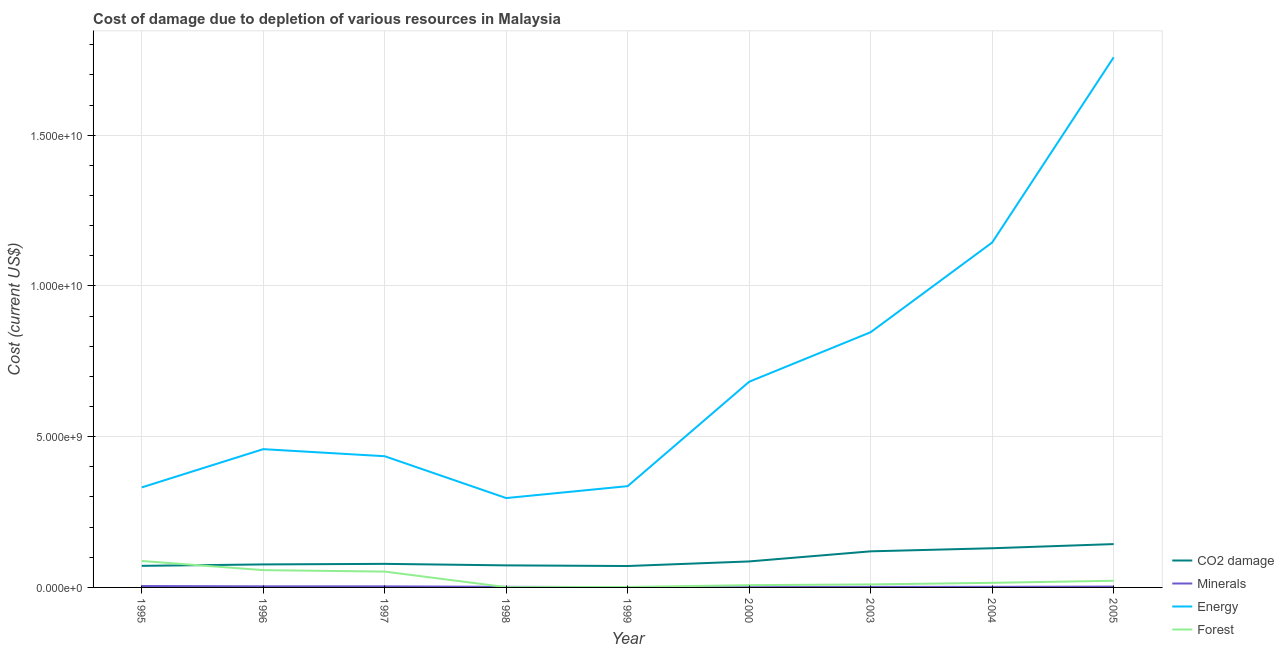How many different coloured lines are there?
Your response must be concise. 4. What is the cost of damage due to depletion of forests in 1995?
Your answer should be very brief. 8.77e+08. Across all years, what is the maximum cost of damage due to depletion of coal?
Keep it short and to the point. 1.44e+09. Across all years, what is the minimum cost of damage due to depletion of coal?
Make the answer very short. 7.10e+08. In which year was the cost of damage due to depletion of coal maximum?
Ensure brevity in your answer.  2005. In which year was the cost of damage due to depletion of minerals minimum?
Offer a very short reply. 2000. What is the total cost of damage due to depletion of minerals in the graph?
Offer a very short reply. 2.23e+08. What is the difference between the cost of damage due to depletion of minerals in 1995 and that in 1999?
Offer a very short reply. 3.65e+07. What is the difference between the cost of damage due to depletion of minerals in 1999 and the cost of damage due to depletion of coal in 2005?
Make the answer very short. -1.43e+09. What is the average cost of damage due to depletion of coal per year?
Make the answer very short. 9.44e+08. In the year 1999, what is the difference between the cost of damage due to depletion of coal and cost of damage due to depletion of energy?
Provide a succinct answer. -2.65e+09. In how many years, is the cost of damage due to depletion of minerals greater than 3000000000 US$?
Your answer should be compact. 0. What is the ratio of the cost of damage due to depletion of minerals in 1997 to that in 2005?
Your response must be concise. 1.25. What is the difference between the highest and the second highest cost of damage due to depletion of forests?
Give a very brief answer. 3.04e+08. What is the difference between the highest and the lowest cost of damage due to depletion of forests?
Keep it short and to the point. 8.68e+08. In how many years, is the cost of damage due to depletion of coal greater than the average cost of damage due to depletion of coal taken over all years?
Offer a very short reply. 3. Is it the case that in every year, the sum of the cost of damage due to depletion of energy and cost of damage due to depletion of minerals is greater than the sum of cost of damage due to depletion of forests and cost of damage due to depletion of coal?
Give a very brief answer. Yes. Is it the case that in every year, the sum of the cost of damage due to depletion of coal and cost of damage due to depletion of minerals is greater than the cost of damage due to depletion of energy?
Provide a short and direct response. No. Does the cost of damage due to depletion of coal monotonically increase over the years?
Ensure brevity in your answer.  No. Is the cost of damage due to depletion of forests strictly less than the cost of damage due to depletion of coal over the years?
Your answer should be compact. No. How many years are there in the graph?
Give a very brief answer. 9. Are the values on the major ticks of Y-axis written in scientific E-notation?
Your answer should be very brief. Yes. Does the graph contain any zero values?
Ensure brevity in your answer.  No. Does the graph contain grids?
Your response must be concise. Yes. How many legend labels are there?
Make the answer very short. 4. What is the title of the graph?
Provide a short and direct response. Cost of damage due to depletion of various resources in Malaysia . Does "Services" appear as one of the legend labels in the graph?
Offer a terse response. No. What is the label or title of the Y-axis?
Keep it short and to the point. Cost (current US$). What is the Cost (current US$) of CO2 damage in 1995?
Provide a short and direct response. 7.16e+08. What is the Cost (current US$) of Minerals in 1995?
Your answer should be compact. 4.67e+07. What is the Cost (current US$) in Energy in 1995?
Offer a very short reply. 3.32e+09. What is the Cost (current US$) in Forest in 1995?
Keep it short and to the point. 8.77e+08. What is the Cost (current US$) in CO2 damage in 1996?
Offer a very short reply. 7.63e+08. What is the Cost (current US$) of Minerals in 1996?
Ensure brevity in your answer.  3.65e+07. What is the Cost (current US$) of Energy in 1996?
Your answer should be very brief. 4.59e+09. What is the Cost (current US$) of Forest in 1996?
Provide a succinct answer. 5.74e+08. What is the Cost (current US$) in CO2 damage in 1997?
Provide a short and direct response. 7.82e+08. What is the Cost (current US$) of Minerals in 1997?
Provide a succinct answer. 3.52e+07. What is the Cost (current US$) in Energy in 1997?
Offer a terse response. 4.35e+09. What is the Cost (current US$) of Forest in 1997?
Provide a short and direct response. 5.25e+08. What is the Cost (current US$) of CO2 damage in 1998?
Make the answer very short. 7.32e+08. What is the Cost (current US$) in Minerals in 1998?
Provide a succinct answer. 2.02e+07. What is the Cost (current US$) in Energy in 1998?
Ensure brevity in your answer.  2.96e+09. What is the Cost (current US$) of Forest in 1998?
Your response must be concise. 9.63e+06. What is the Cost (current US$) of CO2 damage in 1999?
Offer a very short reply. 7.10e+08. What is the Cost (current US$) of Minerals in 1999?
Your answer should be compact. 1.02e+07. What is the Cost (current US$) in Energy in 1999?
Keep it short and to the point. 3.36e+09. What is the Cost (current US$) of Forest in 1999?
Provide a succinct answer. 1.46e+07. What is the Cost (current US$) in CO2 damage in 2000?
Make the answer very short. 8.62e+08. What is the Cost (current US$) of Minerals in 2000?
Your answer should be compact. 7.79e+06. What is the Cost (current US$) of Energy in 2000?
Your response must be concise. 6.82e+09. What is the Cost (current US$) of Forest in 2000?
Your response must be concise. 7.52e+07. What is the Cost (current US$) of CO2 damage in 2003?
Ensure brevity in your answer.  1.20e+09. What is the Cost (current US$) in Minerals in 2003?
Your response must be concise. 1.81e+07. What is the Cost (current US$) of Energy in 2003?
Provide a succinct answer. 8.47e+09. What is the Cost (current US$) in Forest in 2003?
Offer a very short reply. 1.00e+08. What is the Cost (current US$) in CO2 damage in 2004?
Ensure brevity in your answer.  1.30e+09. What is the Cost (current US$) in Minerals in 2004?
Provide a succinct answer. 2.03e+07. What is the Cost (current US$) of Energy in 2004?
Ensure brevity in your answer.  1.14e+1. What is the Cost (current US$) in Forest in 2004?
Give a very brief answer. 1.53e+08. What is the Cost (current US$) in CO2 damage in 2005?
Your answer should be very brief. 1.44e+09. What is the Cost (current US$) in Minerals in 2005?
Your answer should be very brief. 2.82e+07. What is the Cost (current US$) of Energy in 2005?
Provide a short and direct response. 1.76e+1. What is the Cost (current US$) in Forest in 2005?
Provide a succinct answer. 2.21e+08. Across all years, what is the maximum Cost (current US$) of CO2 damage?
Your response must be concise. 1.44e+09. Across all years, what is the maximum Cost (current US$) in Minerals?
Keep it short and to the point. 4.67e+07. Across all years, what is the maximum Cost (current US$) in Energy?
Keep it short and to the point. 1.76e+1. Across all years, what is the maximum Cost (current US$) of Forest?
Keep it short and to the point. 8.77e+08. Across all years, what is the minimum Cost (current US$) in CO2 damage?
Your answer should be very brief. 7.10e+08. Across all years, what is the minimum Cost (current US$) in Minerals?
Ensure brevity in your answer.  7.79e+06. Across all years, what is the minimum Cost (current US$) in Energy?
Your response must be concise. 2.96e+09. Across all years, what is the minimum Cost (current US$) in Forest?
Provide a succinct answer. 9.63e+06. What is the total Cost (current US$) in CO2 damage in the graph?
Your answer should be compact. 8.50e+09. What is the total Cost (current US$) of Minerals in the graph?
Your answer should be very brief. 2.23e+08. What is the total Cost (current US$) of Energy in the graph?
Ensure brevity in your answer.  6.29e+1. What is the total Cost (current US$) of Forest in the graph?
Provide a succinct answer. 2.55e+09. What is the difference between the Cost (current US$) of CO2 damage in 1995 and that in 1996?
Provide a short and direct response. -4.75e+07. What is the difference between the Cost (current US$) in Minerals in 1995 and that in 1996?
Your answer should be compact. 1.02e+07. What is the difference between the Cost (current US$) of Energy in 1995 and that in 1996?
Your response must be concise. -1.27e+09. What is the difference between the Cost (current US$) in Forest in 1995 and that in 1996?
Keep it short and to the point. 3.04e+08. What is the difference between the Cost (current US$) of CO2 damage in 1995 and that in 1997?
Offer a very short reply. -6.62e+07. What is the difference between the Cost (current US$) of Minerals in 1995 and that in 1997?
Ensure brevity in your answer.  1.15e+07. What is the difference between the Cost (current US$) of Energy in 1995 and that in 1997?
Your answer should be compact. -1.03e+09. What is the difference between the Cost (current US$) of Forest in 1995 and that in 1997?
Your answer should be compact. 3.52e+08. What is the difference between the Cost (current US$) in CO2 damage in 1995 and that in 1998?
Ensure brevity in your answer.  -1.58e+07. What is the difference between the Cost (current US$) of Minerals in 1995 and that in 1998?
Provide a short and direct response. 2.65e+07. What is the difference between the Cost (current US$) in Energy in 1995 and that in 1998?
Your answer should be compact. 3.54e+08. What is the difference between the Cost (current US$) of Forest in 1995 and that in 1998?
Keep it short and to the point. 8.68e+08. What is the difference between the Cost (current US$) in CO2 damage in 1995 and that in 1999?
Your answer should be compact. 5.41e+06. What is the difference between the Cost (current US$) of Minerals in 1995 and that in 1999?
Provide a succinct answer. 3.65e+07. What is the difference between the Cost (current US$) in Energy in 1995 and that in 1999?
Provide a succinct answer. -4.26e+07. What is the difference between the Cost (current US$) of Forest in 1995 and that in 1999?
Provide a short and direct response. 8.63e+08. What is the difference between the Cost (current US$) of CO2 damage in 1995 and that in 2000?
Offer a very short reply. -1.46e+08. What is the difference between the Cost (current US$) in Minerals in 1995 and that in 2000?
Keep it short and to the point. 3.89e+07. What is the difference between the Cost (current US$) in Energy in 1995 and that in 2000?
Offer a terse response. -3.51e+09. What is the difference between the Cost (current US$) of Forest in 1995 and that in 2000?
Your answer should be compact. 8.02e+08. What is the difference between the Cost (current US$) in CO2 damage in 1995 and that in 2003?
Provide a short and direct response. -4.82e+08. What is the difference between the Cost (current US$) of Minerals in 1995 and that in 2003?
Your answer should be very brief. 2.86e+07. What is the difference between the Cost (current US$) of Energy in 1995 and that in 2003?
Provide a succinct answer. -5.15e+09. What is the difference between the Cost (current US$) of Forest in 1995 and that in 2003?
Provide a short and direct response. 7.77e+08. What is the difference between the Cost (current US$) in CO2 damage in 1995 and that in 2004?
Give a very brief answer. -5.84e+08. What is the difference between the Cost (current US$) in Minerals in 1995 and that in 2004?
Keep it short and to the point. 2.64e+07. What is the difference between the Cost (current US$) in Energy in 1995 and that in 2004?
Offer a very short reply. -8.12e+09. What is the difference between the Cost (current US$) in Forest in 1995 and that in 2004?
Provide a succinct answer. 7.25e+08. What is the difference between the Cost (current US$) in CO2 damage in 1995 and that in 2005?
Provide a succinct answer. -7.22e+08. What is the difference between the Cost (current US$) of Minerals in 1995 and that in 2005?
Keep it short and to the point. 1.85e+07. What is the difference between the Cost (current US$) in Energy in 1995 and that in 2005?
Ensure brevity in your answer.  -1.43e+1. What is the difference between the Cost (current US$) in Forest in 1995 and that in 2005?
Offer a very short reply. 6.56e+08. What is the difference between the Cost (current US$) in CO2 damage in 1996 and that in 1997?
Ensure brevity in your answer.  -1.87e+07. What is the difference between the Cost (current US$) of Minerals in 1996 and that in 1997?
Offer a very short reply. 1.25e+06. What is the difference between the Cost (current US$) of Energy in 1996 and that in 1997?
Offer a very short reply. 2.35e+08. What is the difference between the Cost (current US$) of Forest in 1996 and that in 1997?
Your response must be concise. 4.82e+07. What is the difference between the Cost (current US$) in CO2 damage in 1996 and that in 1998?
Provide a succinct answer. 3.16e+07. What is the difference between the Cost (current US$) of Minerals in 1996 and that in 1998?
Keep it short and to the point. 1.63e+07. What is the difference between the Cost (current US$) in Energy in 1996 and that in 1998?
Your response must be concise. 1.62e+09. What is the difference between the Cost (current US$) in Forest in 1996 and that in 1998?
Your response must be concise. 5.64e+08. What is the difference between the Cost (current US$) of CO2 damage in 1996 and that in 1999?
Your response must be concise. 5.29e+07. What is the difference between the Cost (current US$) in Minerals in 1996 and that in 1999?
Your response must be concise. 2.62e+07. What is the difference between the Cost (current US$) in Energy in 1996 and that in 1999?
Keep it short and to the point. 1.23e+09. What is the difference between the Cost (current US$) in Forest in 1996 and that in 1999?
Offer a terse response. 5.59e+08. What is the difference between the Cost (current US$) of CO2 damage in 1996 and that in 2000?
Your response must be concise. -9.90e+07. What is the difference between the Cost (current US$) of Minerals in 1996 and that in 2000?
Your response must be concise. 2.87e+07. What is the difference between the Cost (current US$) of Energy in 1996 and that in 2000?
Your response must be concise. -2.24e+09. What is the difference between the Cost (current US$) of Forest in 1996 and that in 2000?
Your answer should be very brief. 4.98e+08. What is the difference between the Cost (current US$) of CO2 damage in 1996 and that in 2003?
Your answer should be very brief. -4.34e+08. What is the difference between the Cost (current US$) of Minerals in 1996 and that in 2003?
Your answer should be compact. 1.84e+07. What is the difference between the Cost (current US$) of Energy in 1996 and that in 2003?
Your answer should be compact. -3.88e+09. What is the difference between the Cost (current US$) in Forest in 1996 and that in 2003?
Offer a very short reply. 4.74e+08. What is the difference between the Cost (current US$) of CO2 damage in 1996 and that in 2004?
Keep it short and to the point. -5.36e+08. What is the difference between the Cost (current US$) in Minerals in 1996 and that in 2004?
Your answer should be compact. 1.62e+07. What is the difference between the Cost (current US$) in Energy in 1996 and that in 2004?
Your answer should be very brief. -6.86e+09. What is the difference between the Cost (current US$) of Forest in 1996 and that in 2004?
Your response must be concise. 4.21e+08. What is the difference between the Cost (current US$) of CO2 damage in 1996 and that in 2005?
Offer a terse response. -6.74e+08. What is the difference between the Cost (current US$) in Minerals in 1996 and that in 2005?
Provide a short and direct response. 8.25e+06. What is the difference between the Cost (current US$) in Energy in 1996 and that in 2005?
Ensure brevity in your answer.  -1.30e+1. What is the difference between the Cost (current US$) in Forest in 1996 and that in 2005?
Make the answer very short. 3.52e+08. What is the difference between the Cost (current US$) in CO2 damage in 1997 and that in 1998?
Offer a very short reply. 5.04e+07. What is the difference between the Cost (current US$) in Minerals in 1997 and that in 1998?
Offer a terse response. 1.50e+07. What is the difference between the Cost (current US$) in Energy in 1997 and that in 1998?
Give a very brief answer. 1.39e+09. What is the difference between the Cost (current US$) in Forest in 1997 and that in 1998?
Offer a very short reply. 5.16e+08. What is the difference between the Cost (current US$) of CO2 damage in 1997 and that in 1999?
Offer a terse response. 7.16e+07. What is the difference between the Cost (current US$) of Minerals in 1997 and that in 1999?
Give a very brief answer. 2.50e+07. What is the difference between the Cost (current US$) in Energy in 1997 and that in 1999?
Give a very brief answer. 9.92e+08. What is the difference between the Cost (current US$) in Forest in 1997 and that in 1999?
Give a very brief answer. 5.11e+08. What is the difference between the Cost (current US$) of CO2 damage in 1997 and that in 2000?
Give a very brief answer. -8.03e+07. What is the difference between the Cost (current US$) of Minerals in 1997 and that in 2000?
Your answer should be compact. 2.74e+07. What is the difference between the Cost (current US$) of Energy in 1997 and that in 2000?
Offer a very short reply. -2.47e+09. What is the difference between the Cost (current US$) of Forest in 1997 and that in 2000?
Make the answer very short. 4.50e+08. What is the difference between the Cost (current US$) of CO2 damage in 1997 and that in 2003?
Make the answer very short. -4.15e+08. What is the difference between the Cost (current US$) in Minerals in 1997 and that in 2003?
Offer a very short reply. 1.71e+07. What is the difference between the Cost (current US$) in Energy in 1997 and that in 2003?
Offer a terse response. -4.11e+09. What is the difference between the Cost (current US$) in Forest in 1997 and that in 2003?
Offer a terse response. 4.25e+08. What is the difference between the Cost (current US$) of CO2 damage in 1997 and that in 2004?
Your response must be concise. -5.18e+08. What is the difference between the Cost (current US$) of Minerals in 1997 and that in 2004?
Provide a short and direct response. 1.49e+07. What is the difference between the Cost (current US$) in Energy in 1997 and that in 2004?
Your answer should be very brief. -7.09e+09. What is the difference between the Cost (current US$) in Forest in 1997 and that in 2004?
Make the answer very short. 3.73e+08. What is the difference between the Cost (current US$) of CO2 damage in 1997 and that in 2005?
Your answer should be very brief. -6.56e+08. What is the difference between the Cost (current US$) in Minerals in 1997 and that in 2005?
Provide a succinct answer. 7.00e+06. What is the difference between the Cost (current US$) of Energy in 1997 and that in 2005?
Provide a succinct answer. -1.32e+1. What is the difference between the Cost (current US$) of Forest in 1997 and that in 2005?
Offer a very short reply. 3.04e+08. What is the difference between the Cost (current US$) in CO2 damage in 1998 and that in 1999?
Your response must be concise. 2.12e+07. What is the difference between the Cost (current US$) of Minerals in 1998 and that in 1999?
Your answer should be very brief. 9.93e+06. What is the difference between the Cost (current US$) of Energy in 1998 and that in 1999?
Offer a terse response. -3.96e+08. What is the difference between the Cost (current US$) in Forest in 1998 and that in 1999?
Make the answer very short. -5.00e+06. What is the difference between the Cost (current US$) in CO2 damage in 1998 and that in 2000?
Provide a short and direct response. -1.31e+08. What is the difference between the Cost (current US$) of Minerals in 1998 and that in 2000?
Provide a short and direct response. 1.24e+07. What is the difference between the Cost (current US$) of Energy in 1998 and that in 2000?
Provide a succinct answer. -3.86e+09. What is the difference between the Cost (current US$) of Forest in 1998 and that in 2000?
Keep it short and to the point. -6.56e+07. What is the difference between the Cost (current US$) of CO2 damage in 1998 and that in 2003?
Your answer should be very brief. -4.66e+08. What is the difference between the Cost (current US$) in Minerals in 1998 and that in 2003?
Give a very brief answer. 2.08e+06. What is the difference between the Cost (current US$) in Energy in 1998 and that in 2003?
Your answer should be compact. -5.50e+09. What is the difference between the Cost (current US$) in Forest in 1998 and that in 2003?
Make the answer very short. -9.05e+07. What is the difference between the Cost (current US$) of CO2 damage in 1998 and that in 2004?
Your answer should be very brief. -5.68e+08. What is the difference between the Cost (current US$) of Minerals in 1998 and that in 2004?
Ensure brevity in your answer.  -1.16e+05. What is the difference between the Cost (current US$) in Energy in 1998 and that in 2004?
Offer a terse response. -8.48e+09. What is the difference between the Cost (current US$) of Forest in 1998 and that in 2004?
Make the answer very short. -1.43e+08. What is the difference between the Cost (current US$) of CO2 damage in 1998 and that in 2005?
Keep it short and to the point. -7.06e+08. What is the difference between the Cost (current US$) in Minerals in 1998 and that in 2005?
Provide a succinct answer. -8.04e+06. What is the difference between the Cost (current US$) of Energy in 1998 and that in 2005?
Your answer should be very brief. -1.46e+1. What is the difference between the Cost (current US$) of Forest in 1998 and that in 2005?
Keep it short and to the point. -2.12e+08. What is the difference between the Cost (current US$) in CO2 damage in 1999 and that in 2000?
Provide a short and direct response. -1.52e+08. What is the difference between the Cost (current US$) in Minerals in 1999 and that in 2000?
Your response must be concise. 2.46e+06. What is the difference between the Cost (current US$) of Energy in 1999 and that in 2000?
Ensure brevity in your answer.  -3.46e+09. What is the difference between the Cost (current US$) of Forest in 1999 and that in 2000?
Ensure brevity in your answer.  -6.06e+07. What is the difference between the Cost (current US$) in CO2 damage in 1999 and that in 2003?
Your answer should be very brief. -4.87e+08. What is the difference between the Cost (current US$) of Minerals in 1999 and that in 2003?
Your answer should be very brief. -7.84e+06. What is the difference between the Cost (current US$) of Energy in 1999 and that in 2003?
Your response must be concise. -5.11e+09. What is the difference between the Cost (current US$) in Forest in 1999 and that in 2003?
Your response must be concise. -8.55e+07. What is the difference between the Cost (current US$) in CO2 damage in 1999 and that in 2004?
Give a very brief answer. -5.89e+08. What is the difference between the Cost (current US$) of Minerals in 1999 and that in 2004?
Offer a very short reply. -1.00e+07. What is the difference between the Cost (current US$) of Energy in 1999 and that in 2004?
Provide a succinct answer. -8.08e+09. What is the difference between the Cost (current US$) of Forest in 1999 and that in 2004?
Offer a very short reply. -1.38e+08. What is the difference between the Cost (current US$) of CO2 damage in 1999 and that in 2005?
Provide a succinct answer. -7.27e+08. What is the difference between the Cost (current US$) of Minerals in 1999 and that in 2005?
Make the answer very short. -1.80e+07. What is the difference between the Cost (current US$) of Energy in 1999 and that in 2005?
Your answer should be very brief. -1.42e+1. What is the difference between the Cost (current US$) of Forest in 1999 and that in 2005?
Make the answer very short. -2.07e+08. What is the difference between the Cost (current US$) of CO2 damage in 2000 and that in 2003?
Offer a terse response. -3.35e+08. What is the difference between the Cost (current US$) of Minerals in 2000 and that in 2003?
Ensure brevity in your answer.  -1.03e+07. What is the difference between the Cost (current US$) in Energy in 2000 and that in 2003?
Ensure brevity in your answer.  -1.64e+09. What is the difference between the Cost (current US$) in Forest in 2000 and that in 2003?
Offer a very short reply. -2.49e+07. What is the difference between the Cost (current US$) in CO2 damage in 2000 and that in 2004?
Your response must be concise. -4.37e+08. What is the difference between the Cost (current US$) of Minerals in 2000 and that in 2004?
Give a very brief answer. -1.25e+07. What is the difference between the Cost (current US$) of Energy in 2000 and that in 2004?
Make the answer very short. -4.62e+09. What is the difference between the Cost (current US$) of Forest in 2000 and that in 2004?
Give a very brief answer. -7.73e+07. What is the difference between the Cost (current US$) in CO2 damage in 2000 and that in 2005?
Provide a succinct answer. -5.75e+08. What is the difference between the Cost (current US$) of Minerals in 2000 and that in 2005?
Provide a succinct answer. -2.04e+07. What is the difference between the Cost (current US$) in Energy in 2000 and that in 2005?
Give a very brief answer. -1.08e+1. What is the difference between the Cost (current US$) of Forest in 2000 and that in 2005?
Your answer should be compact. -1.46e+08. What is the difference between the Cost (current US$) of CO2 damage in 2003 and that in 2004?
Offer a terse response. -1.02e+08. What is the difference between the Cost (current US$) of Minerals in 2003 and that in 2004?
Your response must be concise. -2.20e+06. What is the difference between the Cost (current US$) in Energy in 2003 and that in 2004?
Your response must be concise. -2.98e+09. What is the difference between the Cost (current US$) in Forest in 2003 and that in 2004?
Make the answer very short. -5.24e+07. What is the difference between the Cost (current US$) in CO2 damage in 2003 and that in 2005?
Your response must be concise. -2.40e+08. What is the difference between the Cost (current US$) in Minerals in 2003 and that in 2005?
Your response must be concise. -1.01e+07. What is the difference between the Cost (current US$) of Energy in 2003 and that in 2005?
Your answer should be compact. -9.12e+09. What is the difference between the Cost (current US$) in Forest in 2003 and that in 2005?
Provide a short and direct response. -1.21e+08. What is the difference between the Cost (current US$) of CO2 damage in 2004 and that in 2005?
Ensure brevity in your answer.  -1.38e+08. What is the difference between the Cost (current US$) in Minerals in 2004 and that in 2005?
Give a very brief answer. -7.93e+06. What is the difference between the Cost (current US$) in Energy in 2004 and that in 2005?
Keep it short and to the point. -6.14e+09. What is the difference between the Cost (current US$) of Forest in 2004 and that in 2005?
Keep it short and to the point. -6.86e+07. What is the difference between the Cost (current US$) of CO2 damage in 1995 and the Cost (current US$) of Minerals in 1996?
Offer a terse response. 6.79e+08. What is the difference between the Cost (current US$) of CO2 damage in 1995 and the Cost (current US$) of Energy in 1996?
Your response must be concise. -3.87e+09. What is the difference between the Cost (current US$) of CO2 damage in 1995 and the Cost (current US$) of Forest in 1996?
Provide a short and direct response. 1.42e+08. What is the difference between the Cost (current US$) of Minerals in 1995 and the Cost (current US$) of Energy in 1996?
Your response must be concise. -4.54e+09. What is the difference between the Cost (current US$) in Minerals in 1995 and the Cost (current US$) in Forest in 1996?
Give a very brief answer. -5.27e+08. What is the difference between the Cost (current US$) of Energy in 1995 and the Cost (current US$) of Forest in 1996?
Offer a very short reply. 2.74e+09. What is the difference between the Cost (current US$) of CO2 damage in 1995 and the Cost (current US$) of Minerals in 1997?
Provide a succinct answer. 6.81e+08. What is the difference between the Cost (current US$) in CO2 damage in 1995 and the Cost (current US$) in Energy in 1997?
Make the answer very short. -3.64e+09. What is the difference between the Cost (current US$) of CO2 damage in 1995 and the Cost (current US$) of Forest in 1997?
Offer a terse response. 1.90e+08. What is the difference between the Cost (current US$) in Minerals in 1995 and the Cost (current US$) in Energy in 1997?
Your response must be concise. -4.31e+09. What is the difference between the Cost (current US$) of Minerals in 1995 and the Cost (current US$) of Forest in 1997?
Ensure brevity in your answer.  -4.79e+08. What is the difference between the Cost (current US$) of Energy in 1995 and the Cost (current US$) of Forest in 1997?
Offer a terse response. 2.79e+09. What is the difference between the Cost (current US$) of CO2 damage in 1995 and the Cost (current US$) of Minerals in 1998?
Ensure brevity in your answer.  6.96e+08. What is the difference between the Cost (current US$) in CO2 damage in 1995 and the Cost (current US$) in Energy in 1998?
Offer a terse response. -2.25e+09. What is the difference between the Cost (current US$) of CO2 damage in 1995 and the Cost (current US$) of Forest in 1998?
Your answer should be very brief. 7.06e+08. What is the difference between the Cost (current US$) of Minerals in 1995 and the Cost (current US$) of Energy in 1998?
Your response must be concise. -2.92e+09. What is the difference between the Cost (current US$) of Minerals in 1995 and the Cost (current US$) of Forest in 1998?
Offer a terse response. 3.71e+07. What is the difference between the Cost (current US$) in Energy in 1995 and the Cost (current US$) in Forest in 1998?
Your response must be concise. 3.31e+09. What is the difference between the Cost (current US$) in CO2 damage in 1995 and the Cost (current US$) in Minerals in 1999?
Your answer should be compact. 7.06e+08. What is the difference between the Cost (current US$) of CO2 damage in 1995 and the Cost (current US$) of Energy in 1999?
Ensure brevity in your answer.  -2.64e+09. What is the difference between the Cost (current US$) of CO2 damage in 1995 and the Cost (current US$) of Forest in 1999?
Your answer should be very brief. 7.01e+08. What is the difference between the Cost (current US$) in Minerals in 1995 and the Cost (current US$) in Energy in 1999?
Provide a short and direct response. -3.31e+09. What is the difference between the Cost (current US$) of Minerals in 1995 and the Cost (current US$) of Forest in 1999?
Offer a very short reply. 3.21e+07. What is the difference between the Cost (current US$) of Energy in 1995 and the Cost (current US$) of Forest in 1999?
Provide a succinct answer. 3.30e+09. What is the difference between the Cost (current US$) of CO2 damage in 1995 and the Cost (current US$) of Minerals in 2000?
Offer a terse response. 7.08e+08. What is the difference between the Cost (current US$) of CO2 damage in 1995 and the Cost (current US$) of Energy in 2000?
Keep it short and to the point. -6.11e+09. What is the difference between the Cost (current US$) in CO2 damage in 1995 and the Cost (current US$) in Forest in 2000?
Your answer should be compact. 6.41e+08. What is the difference between the Cost (current US$) in Minerals in 1995 and the Cost (current US$) in Energy in 2000?
Make the answer very short. -6.78e+09. What is the difference between the Cost (current US$) of Minerals in 1995 and the Cost (current US$) of Forest in 2000?
Your answer should be compact. -2.85e+07. What is the difference between the Cost (current US$) of Energy in 1995 and the Cost (current US$) of Forest in 2000?
Keep it short and to the point. 3.24e+09. What is the difference between the Cost (current US$) in CO2 damage in 1995 and the Cost (current US$) in Minerals in 2003?
Your response must be concise. 6.98e+08. What is the difference between the Cost (current US$) in CO2 damage in 1995 and the Cost (current US$) in Energy in 2003?
Give a very brief answer. -7.75e+09. What is the difference between the Cost (current US$) of CO2 damage in 1995 and the Cost (current US$) of Forest in 2003?
Your response must be concise. 6.16e+08. What is the difference between the Cost (current US$) of Minerals in 1995 and the Cost (current US$) of Energy in 2003?
Give a very brief answer. -8.42e+09. What is the difference between the Cost (current US$) of Minerals in 1995 and the Cost (current US$) of Forest in 2003?
Ensure brevity in your answer.  -5.34e+07. What is the difference between the Cost (current US$) in Energy in 1995 and the Cost (current US$) in Forest in 2003?
Your answer should be compact. 3.22e+09. What is the difference between the Cost (current US$) in CO2 damage in 1995 and the Cost (current US$) in Minerals in 2004?
Your answer should be compact. 6.96e+08. What is the difference between the Cost (current US$) in CO2 damage in 1995 and the Cost (current US$) in Energy in 2004?
Offer a terse response. -1.07e+1. What is the difference between the Cost (current US$) of CO2 damage in 1995 and the Cost (current US$) of Forest in 2004?
Offer a terse response. 5.63e+08. What is the difference between the Cost (current US$) of Minerals in 1995 and the Cost (current US$) of Energy in 2004?
Your response must be concise. -1.14e+1. What is the difference between the Cost (current US$) of Minerals in 1995 and the Cost (current US$) of Forest in 2004?
Your response must be concise. -1.06e+08. What is the difference between the Cost (current US$) in Energy in 1995 and the Cost (current US$) in Forest in 2004?
Your response must be concise. 3.17e+09. What is the difference between the Cost (current US$) in CO2 damage in 1995 and the Cost (current US$) in Minerals in 2005?
Make the answer very short. 6.88e+08. What is the difference between the Cost (current US$) in CO2 damage in 1995 and the Cost (current US$) in Energy in 2005?
Provide a succinct answer. -1.69e+1. What is the difference between the Cost (current US$) in CO2 damage in 1995 and the Cost (current US$) in Forest in 2005?
Your response must be concise. 4.95e+08. What is the difference between the Cost (current US$) of Minerals in 1995 and the Cost (current US$) of Energy in 2005?
Make the answer very short. -1.75e+1. What is the difference between the Cost (current US$) in Minerals in 1995 and the Cost (current US$) in Forest in 2005?
Provide a short and direct response. -1.75e+08. What is the difference between the Cost (current US$) in Energy in 1995 and the Cost (current US$) in Forest in 2005?
Provide a short and direct response. 3.10e+09. What is the difference between the Cost (current US$) of CO2 damage in 1996 and the Cost (current US$) of Minerals in 1997?
Your response must be concise. 7.28e+08. What is the difference between the Cost (current US$) in CO2 damage in 1996 and the Cost (current US$) in Energy in 1997?
Keep it short and to the point. -3.59e+09. What is the difference between the Cost (current US$) of CO2 damage in 1996 and the Cost (current US$) of Forest in 1997?
Your answer should be compact. 2.38e+08. What is the difference between the Cost (current US$) in Minerals in 1996 and the Cost (current US$) in Energy in 1997?
Your response must be concise. -4.32e+09. What is the difference between the Cost (current US$) of Minerals in 1996 and the Cost (current US$) of Forest in 1997?
Keep it short and to the point. -4.89e+08. What is the difference between the Cost (current US$) of Energy in 1996 and the Cost (current US$) of Forest in 1997?
Ensure brevity in your answer.  4.06e+09. What is the difference between the Cost (current US$) of CO2 damage in 1996 and the Cost (current US$) of Minerals in 1998?
Provide a succinct answer. 7.43e+08. What is the difference between the Cost (current US$) of CO2 damage in 1996 and the Cost (current US$) of Energy in 1998?
Your answer should be very brief. -2.20e+09. What is the difference between the Cost (current US$) in CO2 damage in 1996 and the Cost (current US$) in Forest in 1998?
Your answer should be compact. 7.54e+08. What is the difference between the Cost (current US$) of Minerals in 1996 and the Cost (current US$) of Energy in 1998?
Keep it short and to the point. -2.93e+09. What is the difference between the Cost (current US$) in Minerals in 1996 and the Cost (current US$) in Forest in 1998?
Ensure brevity in your answer.  2.68e+07. What is the difference between the Cost (current US$) of Energy in 1996 and the Cost (current US$) of Forest in 1998?
Offer a very short reply. 4.58e+09. What is the difference between the Cost (current US$) of CO2 damage in 1996 and the Cost (current US$) of Minerals in 1999?
Offer a very short reply. 7.53e+08. What is the difference between the Cost (current US$) in CO2 damage in 1996 and the Cost (current US$) in Energy in 1999?
Ensure brevity in your answer.  -2.60e+09. What is the difference between the Cost (current US$) of CO2 damage in 1996 and the Cost (current US$) of Forest in 1999?
Make the answer very short. 7.49e+08. What is the difference between the Cost (current US$) of Minerals in 1996 and the Cost (current US$) of Energy in 1999?
Ensure brevity in your answer.  -3.32e+09. What is the difference between the Cost (current US$) of Minerals in 1996 and the Cost (current US$) of Forest in 1999?
Make the answer very short. 2.18e+07. What is the difference between the Cost (current US$) of Energy in 1996 and the Cost (current US$) of Forest in 1999?
Make the answer very short. 4.57e+09. What is the difference between the Cost (current US$) of CO2 damage in 1996 and the Cost (current US$) of Minerals in 2000?
Offer a terse response. 7.55e+08. What is the difference between the Cost (current US$) of CO2 damage in 1996 and the Cost (current US$) of Energy in 2000?
Offer a terse response. -6.06e+09. What is the difference between the Cost (current US$) in CO2 damage in 1996 and the Cost (current US$) in Forest in 2000?
Your answer should be very brief. 6.88e+08. What is the difference between the Cost (current US$) in Minerals in 1996 and the Cost (current US$) in Energy in 2000?
Give a very brief answer. -6.79e+09. What is the difference between the Cost (current US$) of Minerals in 1996 and the Cost (current US$) of Forest in 2000?
Give a very brief answer. -3.88e+07. What is the difference between the Cost (current US$) of Energy in 1996 and the Cost (current US$) of Forest in 2000?
Offer a terse response. 4.51e+09. What is the difference between the Cost (current US$) of CO2 damage in 1996 and the Cost (current US$) of Minerals in 2003?
Ensure brevity in your answer.  7.45e+08. What is the difference between the Cost (current US$) of CO2 damage in 1996 and the Cost (current US$) of Energy in 2003?
Provide a succinct answer. -7.70e+09. What is the difference between the Cost (current US$) of CO2 damage in 1996 and the Cost (current US$) of Forest in 2003?
Provide a short and direct response. 6.63e+08. What is the difference between the Cost (current US$) of Minerals in 1996 and the Cost (current US$) of Energy in 2003?
Your answer should be compact. -8.43e+09. What is the difference between the Cost (current US$) of Minerals in 1996 and the Cost (current US$) of Forest in 2003?
Give a very brief answer. -6.37e+07. What is the difference between the Cost (current US$) in Energy in 1996 and the Cost (current US$) in Forest in 2003?
Your response must be concise. 4.49e+09. What is the difference between the Cost (current US$) in CO2 damage in 1996 and the Cost (current US$) in Minerals in 2004?
Provide a short and direct response. 7.43e+08. What is the difference between the Cost (current US$) in CO2 damage in 1996 and the Cost (current US$) in Energy in 2004?
Provide a short and direct response. -1.07e+1. What is the difference between the Cost (current US$) of CO2 damage in 1996 and the Cost (current US$) of Forest in 2004?
Your answer should be very brief. 6.11e+08. What is the difference between the Cost (current US$) in Minerals in 1996 and the Cost (current US$) in Energy in 2004?
Keep it short and to the point. -1.14e+1. What is the difference between the Cost (current US$) in Minerals in 1996 and the Cost (current US$) in Forest in 2004?
Keep it short and to the point. -1.16e+08. What is the difference between the Cost (current US$) in Energy in 1996 and the Cost (current US$) in Forest in 2004?
Your response must be concise. 4.43e+09. What is the difference between the Cost (current US$) of CO2 damage in 1996 and the Cost (current US$) of Minerals in 2005?
Keep it short and to the point. 7.35e+08. What is the difference between the Cost (current US$) of CO2 damage in 1996 and the Cost (current US$) of Energy in 2005?
Keep it short and to the point. -1.68e+1. What is the difference between the Cost (current US$) in CO2 damage in 1996 and the Cost (current US$) in Forest in 2005?
Make the answer very short. 5.42e+08. What is the difference between the Cost (current US$) of Minerals in 1996 and the Cost (current US$) of Energy in 2005?
Keep it short and to the point. -1.75e+1. What is the difference between the Cost (current US$) in Minerals in 1996 and the Cost (current US$) in Forest in 2005?
Provide a short and direct response. -1.85e+08. What is the difference between the Cost (current US$) in Energy in 1996 and the Cost (current US$) in Forest in 2005?
Offer a terse response. 4.37e+09. What is the difference between the Cost (current US$) of CO2 damage in 1997 and the Cost (current US$) of Minerals in 1998?
Provide a short and direct response. 7.62e+08. What is the difference between the Cost (current US$) of CO2 damage in 1997 and the Cost (current US$) of Energy in 1998?
Offer a very short reply. -2.18e+09. What is the difference between the Cost (current US$) of CO2 damage in 1997 and the Cost (current US$) of Forest in 1998?
Offer a terse response. 7.72e+08. What is the difference between the Cost (current US$) of Minerals in 1997 and the Cost (current US$) of Energy in 1998?
Provide a succinct answer. -2.93e+09. What is the difference between the Cost (current US$) in Minerals in 1997 and the Cost (current US$) in Forest in 1998?
Offer a terse response. 2.56e+07. What is the difference between the Cost (current US$) in Energy in 1997 and the Cost (current US$) in Forest in 1998?
Offer a terse response. 4.34e+09. What is the difference between the Cost (current US$) of CO2 damage in 1997 and the Cost (current US$) of Minerals in 1999?
Your answer should be very brief. 7.72e+08. What is the difference between the Cost (current US$) in CO2 damage in 1997 and the Cost (current US$) in Energy in 1999?
Give a very brief answer. -2.58e+09. What is the difference between the Cost (current US$) of CO2 damage in 1997 and the Cost (current US$) of Forest in 1999?
Offer a very short reply. 7.67e+08. What is the difference between the Cost (current US$) in Minerals in 1997 and the Cost (current US$) in Energy in 1999?
Offer a very short reply. -3.33e+09. What is the difference between the Cost (current US$) in Minerals in 1997 and the Cost (current US$) in Forest in 1999?
Your answer should be very brief. 2.06e+07. What is the difference between the Cost (current US$) of Energy in 1997 and the Cost (current US$) of Forest in 1999?
Your answer should be very brief. 4.34e+09. What is the difference between the Cost (current US$) in CO2 damage in 1997 and the Cost (current US$) in Minerals in 2000?
Provide a short and direct response. 7.74e+08. What is the difference between the Cost (current US$) of CO2 damage in 1997 and the Cost (current US$) of Energy in 2000?
Your answer should be compact. -6.04e+09. What is the difference between the Cost (current US$) of CO2 damage in 1997 and the Cost (current US$) of Forest in 2000?
Provide a short and direct response. 7.07e+08. What is the difference between the Cost (current US$) of Minerals in 1997 and the Cost (current US$) of Energy in 2000?
Provide a succinct answer. -6.79e+09. What is the difference between the Cost (current US$) in Minerals in 1997 and the Cost (current US$) in Forest in 2000?
Your answer should be compact. -4.00e+07. What is the difference between the Cost (current US$) of Energy in 1997 and the Cost (current US$) of Forest in 2000?
Offer a terse response. 4.28e+09. What is the difference between the Cost (current US$) of CO2 damage in 1997 and the Cost (current US$) of Minerals in 2003?
Your answer should be compact. 7.64e+08. What is the difference between the Cost (current US$) in CO2 damage in 1997 and the Cost (current US$) in Energy in 2003?
Offer a very short reply. -7.68e+09. What is the difference between the Cost (current US$) in CO2 damage in 1997 and the Cost (current US$) in Forest in 2003?
Keep it short and to the point. 6.82e+08. What is the difference between the Cost (current US$) in Minerals in 1997 and the Cost (current US$) in Energy in 2003?
Your answer should be compact. -8.43e+09. What is the difference between the Cost (current US$) in Minerals in 1997 and the Cost (current US$) in Forest in 2003?
Ensure brevity in your answer.  -6.49e+07. What is the difference between the Cost (current US$) of Energy in 1997 and the Cost (current US$) of Forest in 2003?
Provide a short and direct response. 4.25e+09. What is the difference between the Cost (current US$) of CO2 damage in 1997 and the Cost (current US$) of Minerals in 2004?
Ensure brevity in your answer.  7.62e+08. What is the difference between the Cost (current US$) in CO2 damage in 1997 and the Cost (current US$) in Energy in 2004?
Your answer should be compact. -1.07e+1. What is the difference between the Cost (current US$) of CO2 damage in 1997 and the Cost (current US$) of Forest in 2004?
Offer a very short reply. 6.29e+08. What is the difference between the Cost (current US$) in Minerals in 1997 and the Cost (current US$) in Energy in 2004?
Make the answer very short. -1.14e+1. What is the difference between the Cost (current US$) in Minerals in 1997 and the Cost (current US$) in Forest in 2004?
Offer a very short reply. -1.17e+08. What is the difference between the Cost (current US$) of Energy in 1997 and the Cost (current US$) of Forest in 2004?
Your response must be concise. 4.20e+09. What is the difference between the Cost (current US$) of CO2 damage in 1997 and the Cost (current US$) of Minerals in 2005?
Make the answer very short. 7.54e+08. What is the difference between the Cost (current US$) in CO2 damage in 1997 and the Cost (current US$) in Energy in 2005?
Offer a very short reply. -1.68e+1. What is the difference between the Cost (current US$) of CO2 damage in 1997 and the Cost (current US$) of Forest in 2005?
Provide a short and direct response. 5.61e+08. What is the difference between the Cost (current US$) of Minerals in 1997 and the Cost (current US$) of Energy in 2005?
Your answer should be compact. -1.75e+1. What is the difference between the Cost (current US$) of Minerals in 1997 and the Cost (current US$) of Forest in 2005?
Make the answer very short. -1.86e+08. What is the difference between the Cost (current US$) of Energy in 1997 and the Cost (current US$) of Forest in 2005?
Offer a terse response. 4.13e+09. What is the difference between the Cost (current US$) in CO2 damage in 1998 and the Cost (current US$) in Minerals in 1999?
Offer a terse response. 7.21e+08. What is the difference between the Cost (current US$) of CO2 damage in 1998 and the Cost (current US$) of Energy in 1999?
Offer a very short reply. -2.63e+09. What is the difference between the Cost (current US$) of CO2 damage in 1998 and the Cost (current US$) of Forest in 1999?
Make the answer very short. 7.17e+08. What is the difference between the Cost (current US$) in Minerals in 1998 and the Cost (current US$) in Energy in 1999?
Ensure brevity in your answer.  -3.34e+09. What is the difference between the Cost (current US$) of Minerals in 1998 and the Cost (current US$) of Forest in 1999?
Provide a succinct answer. 5.55e+06. What is the difference between the Cost (current US$) in Energy in 1998 and the Cost (current US$) in Forest in 1999?
Ensure brevity in your answer.  2.95e+09. What is the difference between the Cost (current US$) in CO2 damage in 1998 and the Cost (current US$) in Minerals in 2000?
Offer a very short reply. 7.24e+08. What is the difference between the Cost (current US$) in CO2 damage in 1998 and the Cost (current US$) in Energy in 2000?
Keep it short and to the point. -6.09e+09. What is the difference between the Cost (current US$) of CO2 damage in 1998 and the Cost (current US$) of Forest in 2000?
Give a very brief answer. 6.56e+08. What is the difference between the Cost (current US$) in Minerals in 1998 and the Cost (current US$) in Energy in 2000?
Give a very brief answer. -6.80e+09. What is the difference between the Cost (current US$) in Minerals in 1998 and the Cost (current US$) in Forest in 2000?
Make the answer very short. -5.51e+07. What is the difference between the Cost (current US$) of Energy in 1998 and the Cost (current US$) of Forest in 2000?
Your response must be concise. 2.89e+09. What is the difference between the Cost (current US$) of CO2 damage in 1998 and the Cost (current US$) of Minerals in 2003?
Provide a succinct answer. 7.14e+08. What is the difference between the Cost (current US$) in CO2 damage in 1998 and the Cost (current US$) in Energy in 2003?
Provide a short and direct response. -7.73e+09. What is the difference between the Cost (current US$) in CO2 damage in 1998 and the Cost (current US$) in Forest in 2003?
Give a very brief answer. 6.31e+08. What is the difference between the Cost (current US$) in Minerals in 1998 and the Cost (current US$) in Energy in 2003?
Ensure brevity in your answer.  -8.45e+09. What is the difference between the Cost (current US$) of Minerals in 1998 and the Cost (current US$) of Forest in 2003?
Give a very brief answer. -8.00e+07. What is the difference between the Cost (current US$) in Energy in 1998 and the Cost (current US$) in Forest in 2003?
Your answer should be compact. 2.86e+09. What is the difference between the Cost (current US$) of CO2 damage in 1998 and the Cost (current US$) of Minerals in 2004?
Your response must be concise. 7.11e+08. What is the difference between the Cost (current US$) of CO2 damage in 1998 and the Cost (current US$) of Energy in 2004?
Give a very brief answer. -1.07e+1. What is the difference between the Cost (current US$) in CO2 damage in 1998 and the Cost (current US$) in Forest in 2004?
Make the answer very short. 5.79e+08. What is the difference between the Cost (current US$) in Minerals in 1998 and the Cost (current US$) in Energy in 2004?
Make the answer very short. -1.14e+1. What is the difference between the Cost (current US$) of Minerals in 1998 and the Cost (current US$) of Forest in 2004?
Ensure brevity in your answer.  -1.32e+08. What is the difference between the Cost (current US$) in Energy in 1998 and the Cost (current US$) in Forest in 2004?
Your answer should be compact. 2.81e+09. What is the difference between the Cost (current US$) of CO2 damage in 1998 and the Cost (current US$) of Minerals in 2005?
Your response must be concise. 7.03e+08. What is the difference between the Cost (current US$) of CO2 damage in 1998 and the Cost (current US$) of Energy in 2005?
Keep it short and to the point. -1.69e+1. What is the difference between the Cost (current US$) in CO2 damage in 1998 and the Cost (current US$) in Forest in 2005?
Offer a very short reply. 5.10e+08. What is the difference between the Cost (current US$) in Minerals in 1998 and the Cost (current US$) in Energy in 2005?
Provide a succinct answer. -1.76e+1. What is the difference between the Cost (current US$) in Minerals in 1998 and the Cost (current US$) in Forest in 2005?
Offer a terse response. -2.01e+08. What is the difference between the Cost (current US$) of Energy in 1998 and the Cost (current US$) of Forest in 2005?
Offer a terse response. 2.74e+09. What is the difference between the Cost (current US$) in CO2 damage in 1999 and the Cost (current US$) in Minerals in 2000?
Make the answer very short. 7.03e+08. What is the difference between the Cost (current US$) in CO2 damage in 1999 and the Cost (current US$) in Energy in 2000?
Make the answer very short. -6.11e+09. What is the difference between the Cost (current US$) of CO2 damage in 1999 and the Cost (current US$) of Forest in 2000?
Ensure brevity in your answer.  6.35e+08. What is the difference between the Cost (current US$) of Minerals in 1999 and the Cost (current US$) of Energy in 2000?
Offer a very short reply. -6.81e+09. What is the difference between the Cost (current US$) of Minerals in 1999 and the Cost (current US$) of Forest in 2000?
Ensure brevity in your answer.  -6.50e+07. What is the difference between the Cost (current US$) of Energy in 1999 and the Cost (current US$) of Forest in 2000?
Offer a terse response. 3.29e+09. What is the difference between the Cost (current US$) of CO2 damage in 1999 and the Cost (current US$) of Minerals in 2003?
Ensure brevity in your answer.  6.92e+08. What is the difference between the Cost (current US$) of CO2 damage in 1999 and the Cost (current US$) of Energy in 2003?
Ensure brevity in your answer.  -7.76e+09. What is the difference between the Cost (current US$) in CO2 damage in 1999 and the Cost (current US$) in Forest in 2003?
Your answer should be very brief. 6.10e+08. What is the difference between the Cost (current US$) of Minerals in 1999 and the Cost (current US$) of Energy in 2003?
Your response must be concise. -8.46e+09. What is the difference between the Cost (current US$) in Minerals in 1999 and the Cost (current US$) in Forest in 2003?
Your answer should be compact. -8.99e+07. What is the difference between the Cost (current US$) in Energy in 1999 and the Cost (current US$) in Forest in 2003?
Keep it short and to the point. 3.26e+09. What is the difference between the Cost (current US$) of CO2 damage in 1999 and the Cost (current US$) of Minerals in 2004?
Provide a succinct answer. 6.90e+08. What is the difference between the Cost (current US$) of CO2 damage in 1999 and the Cost (current US$) of Energy in 2004?
Your answer should be very brief. -1.07e+1. What is the difference between the Cost (current US$) of CO2 damage in 1999 and the Cost (current US$) of Forest in 2004?
Provide a succinct answer. 5.58e+08. What is the difference between the Cost (current US$) of Minerals in 1999 and the Cost (current US$) of Energy in 2004?
Provide a short and direct response. -1.14e+1. What is the difference between the Cost (current US$) in Minerals in 1999 and the Cost (current US$) in Forest in 2004?
Your response must be concise. -1.42e+08. What is the difference between the Cost (current US$) of Energy in 1999 and the Cost (current US$) of Forest in 2004?
Make the answer very short. 3.21e+09. What is the difference between the Cost (current US$) in CO2 damage in 1999 and the Cost (current US$) in Minerals in 2005?
Offer a terse response. 6.82e+08. What is the difference between the Cost (current US$) in CO2 damage in 1999 and the Cost (current US$) in Energy in 2005?
Give a very brief answer. -1.69e+1. What is the difference between the Cost (current US$) of CO2 damage in 1999 and the Cost (current US$) of Forest in 2005?
Your answer should be very brief. 4.89e+08. What is the difference between the Cost (current US$) in Minerals in 1999 and the Cost (current US$) in Energy in 2005?
Your answer should be very brief. -1.76e+1. What is the difference between the Cost (current US$) of Minerals in 1999 and the Cost (current US$) of Forest in 2005?
Give a very brief answer. -2.11e+08. What is the difference between the Cost (current US$) in Energy in 1999 and the Cost (current US$) in Forest in 2005?
Provide a succinct answer. 3.14e+09. What is the difference between the Cost (current US$) in CO2 damage in 2000 and the Cost (current US$) in Minerals in 2003?
Your answer should be very brief. 8.44e+08. What is the difference between the Cost (current US$) of CO2 damage in 2000 and the Cost (current US$) of Energy in 2003?
Keep it short and to the point. -7.60e+09. What is the difference between the Cost (current US$) in CO2 damage in 2000 and the Cost (current US$) in Forest in 2003?
Your answer should be compact. 7.62e+08. What is the difference between the Cost (current US$) in Minerals in 2000 and the Cost (current US$) in Energy in 2003?
Your answer should be very brief. -8.46e+09. What is the difference between the Cost (current US$) of Minerals in 2000 and the Cost (current US$) of Forest in 2003?
Your response must be concise. -9.24e+07. What is the difference between the Cost (current US$) in Energy in 2000 and the Cost (current US$) in Forest in 2003?
Ensure brevity in your answer.  6.72e+09. What is the difference between the Cost (current US$) of CO2 damage in 2000 and the Cost (current US$) of Minerals in 2004?
Offer a very short reply. 8.42e+08. What is the difference between the Cost (current US$) in CO2 damage in 2000 and the Cost (current US$) in Energy in 2004?
Ensure brevity in your answer.  -1.06e+1. What is the difference between the Cost (current US$) in CO2 damage in 2000 and the Cost (current US$) in Forest in 2004?
Ensure brevity in your answer.  7.10e+08. What is the difference between the Cost (current US$) in Minerals in 2000 and the Cost (current US$) in Energy in 2004?
Offer a very short reply. -1.14e+1. What is the difference between the Cost (current US$) of Minerals in 2000 and the Cost (current US$) of Forest in 2004?
Keep it short and to the point. -1.45e+08. What is the difference between the Cost (current US$) in Energy in 2000 and the Cost (current US$) in Forest in 2004?
Give a very brief answer. 6.67e+09. What is the difference between the Cost (current US$) in CO2 damage in 2000 and the Cost (current US$) in Minerals in 2005?
Provide a short and direct response. 8.34e+08. What is the difference between the Cost (current US$) in CO2 damage in 2000 and the Cost (current US$) in Energy in 2005?
Make the answer very short. -1.67e+1. What is the difference between the Cost (current US$) in CO2 damage in 2000 and the Cost (current US$) in Forest in 2005?
Keep it short and to the point. 6.41e+08. What is the difference between the Cost (current US$) in Minerals in 2000 and the Cost (current US$) in Energy in 2005?
Your answer should be very brief. -1.76e+1. What is the difference between the Cost (current US$) of Minerals in 2000 and the Cost (current US$) of Forest in 2005?
Give a very brief answer. -2.13e+08. What is the difference between the Cost (current US$) in Energy in 2000 and the Cost (current US$) in Forest in 2005?
Your answer should be compact. 6.60e+09. What is the difference between the Cost (current US$) in CO2 damage in 2003 and the Cost (current US$) in Minerals in 2004?
Offer a terse response. 1.18e+09. What is the difference between the Cost (current US$) of CO2 damage in 2003 and the Cost (current US$) of Energy in 2004?
Your response must be concise. -1.02e+1. What is the difference between the Cost (current US$) of CO2 damage in 2003 and the Cost (current US$) of Forest in 2004?
Your answer should be compact. 1.04e+09. What is the difference between the Cost (current US$) in Minerals in 2003 and the Cost (current US$) in Energy in 2004?
Keep it short and to the point. -1.14e+1. What is the difference between the Cost (current US$) in Minerals in 2003 and the Cost (current US$) in Forest in 2004?
Ensure brevity in your answer.  -1.34e+08. What is the difference between the Cost (current US$) in Energy in 2003 and the Cost (current US$) in Forest in 2004?
Provide a succinct answer. 8.31e+09. What is the difference between the Cost (current US$) in CO2 damage in 2003 and the Cost (current US$) in Minerals in 2005?
Give a very brief answer. 1.17e+09. What is the difference between the Cost (current US$) in CO2 damage in 2003 and the Cost (current US$) in Energy in 2005?
Your answer should be very brief. -1.64e+1. What is the difference between the Cost (current US$) in CO2 damage in 2003 and the Cost (current US$) in Forest in 2005?
Provide a short and direct response. 9.76e+08. What is the difference between the Cost (current US$) in Minerals in 2003 and the Cost (current US$) in Energy in 2005?
Ensure brevity in your answer.  -1.76e+1. What is the difference between the Cost (current US$) of Minerals in 2003 and the Cost (current US$) of Forest in 2005?
Offer a very short reply. -2.03e+08. What is the difference between the Cost (current US$) in Energy in 2003 and the Cost (current US$) in Forest in 2005?
Your answer should be very brief. 8.25e+09. What is the difference between the Cost (current US$) of CO2 damage in 2004 and the Cost (current US$) of Minerals in 2005?
Give a very brief answer. 1.27e+09. What is the difference between the Cost (current US$) of CO2 damage in 2004 and the Cost (current US$) of Energy in 2005?
Provide a succinct answer. -1.63e+1. What is the difference between the Cost (current US$) of CO2 damage in 2004 and the Cost (current US$) of Forest in 2005?
Ensure brevity in your answer.  1.08e+09. What is the difference between the Cost (current US$) of Minerals in 2004 and the Cost (current US$) of Energy in 2005?
Make the answer very short. -1.76e+1. What is the difference between the Cost (current US$) of Minerals in 2004 and the Cost (current US$) of Forest in 2005?
Your answer should be very brief. -2.01e+08. What is the difference between the Cost (current US$) in Energy in 2004 and the Cost (current US$) in Forest in 2005?
Make the answer very short. 1.12e+1. What is the average Cost (current US$) of CO2 damage per year?
Offer a very short reply. 9.44e+08. What is the average Cost (current US$) in Minerals per year?
Your response must be concise. 2.48e+07. What is the average Cost (current US$) in Energy per year?
Offer a terse response. 6.99e+09. What is the average Cost (current US$) in Forest per year?
Your answer should be compact. 2.83e+08. In the year 1995, what is the difference between the Cost (current US$) in CO2 damage and Cost (current US$) in Minerals?
Ensure brevity in your answer.  6.69e+08. In the year 1995, what is the difference between the Cost (current US$) in CO2 damage and Cost (current US$) in Energy?
Keep it short and to the point. -2.60e+09. In the year 1995, what is the difference between the Cost (current US$) of CO2 damage and Cost (current US$) of Forest?
Give a very brief answer. -1.62e+08. In the year 1995, what is the difference between the Cost (current US$) in Minerals and Cost (current US$) in Energy?
Provide a succinct answer. -3.27e+09. In the year 1995, what is the difference between the Cost (current US$) in Minerals and Cost (current US$) in Forest?
Make the answer very short. -8.31e+08. In the year 1995, what is the difference between the Cost (current US$) of Energy and Cost (current US$) of Forest?
Ensure brevity in your answer.  2.44e+09. In the year 1996, what is the difference between the Cost (current US$) in CO2 damage and Cost (current US$) in Minerals?
Your response must be concise. 7.27e+08. In the year 1996, what is the difference between the Cost (current US$) of CO2 damage and Cost (current US$) of Energy?
Ensure brevity in your answer.  -3.82e+09. In the year 1996, what is the difference between the Cost (current US$) in CO2 damage and Cost (current US$) in Forest?
Ensure brevity in your answer.  1.90e+08. In the year 1996, what is the difference between the Cost (current US$) of Minerals and Cost (current US$) of Energy?
Provide a succinct answer. -4.55e+09. In the year 1996, what is the difference between the Cost (current US$) of Minerals and Cost (current US$) of Forest?
Provide a succinct answer. -5.37e+08. In the year 1996, what is the difference between the Cost (current US$) in Energy and Cost (current US$) in Forest?
Give a very brief answer. 4.01e+09. In the year 1997, what is the difference between the Cost (current US$) of CO2 damage and Cost (current US$) of Minerals?
Offer a very short reply. 7.47e+08. In the year 1997, what is the difference between the Cost (current US$) of CO2 damage and Cost (current US$) of Energy?
Your response must be concise. -3.57e+09. In the year 1997, what is the difference between the Cost (current US$) of CO2 damage and Cost (current US$) of Forest?
Provide a succinct answer. 2.57e+08. In the year 1997, what is the difference between the Cost (current US$) in Minerals and Cost (current US$) in Energy?
Your response must be concise. -4.32e+09. In the year 1997, what is the difference between the Cost (current US$) of Minerals and Cost (current US$) of Forest?
Offer a very short reply. -4.90e+08. In the year 1997, what is the difference between the Cost (current US$) of Energy and Cost (current US$) of Forest?
Your response must be concise. 3.83e+09. In the year 1998, what is the difference between the Cost (current US$) in CO2 damage and Cost (current US$) in Minerals?
Offer a very short reply. 7.11e+08. In the year 1998, what is the difference between the Cost (current US$) in CO2 damage and Cost (current US$) in Energy?
Make the answer very short. -2.23e+09. In the year 1998, what is the difference between the Cost (current US$) in CO2 damage and Cost (current US$) in Forest?
Offer a very short reply. 7.22e+08. In the year 1998, what is the difference between the Cost (current US$) in Minerals and Cost (current US$) in Energy?
Offer a terse response. -2.94e+09. In the year 1998, what is the difference between the Cost (current US$) in Minerals and Cost (current US$) in Forest?
Ensure brevity in your answer.  1.05e+07. In the year 1998, what is the difference between the Cost (current US$) in Energy and Cost (current US$) in Forest?
Make the answer very short. 2.95e+09. In the year 1999, what is the difference between the Cost (current US$) in CO2 damage and Cost (current US$) in Minerals?
Your answer should be very brief. 7.00e+08. In the year 1999, what is the difference between the Cost (current US$) in CO2 damage and Cost (current US$) in Energy?
Offer a terse response. -2.65e+09. In the year 1999, what is the difference between the Cost (current US$) of CO2 damage and Cost (current US$) of Forest?
Your answer should be compact. 6.96e+08. In the year 1999, what is the difference between the Cost (current US$) in Minerals and Cost (current US$) in Energy?
Offer a very short reply. -3.35e+09. In the year 1999, what is the difference between the Cost (current US$) in Minerals and Cost (current US$) in Forest?
Your answer should be compact. -4.38e+06. In the year 1999, what is the difference between the Cost (current US$) of Energy and Cost (current US$) of Forest?
Keep it short and to the point. 3.35e+09. In the year 2000, what is the difference between the Cost (current US$) in CO2 damage and Cost (current US$) in Minerals?
Keep it short and to the point. 8.54e+08. In the year 2000, what is the difference between the Cost (current US$) in CO2 damage and Cost (current US$) in Energy?
Your response must be concise. -5.96e+09. In the year 2000, what is the difference between the Cost (current US$) in CO2 damage and Cost (current US$) in Forest?
Your answer should be very brief. 7.87e+08. In the year 2000, what is the difference between the Cost (current US$) of Minerals and Cost (current US$) of Energy?
Provide a short and direct response. -6.82e+09. In the year 2000, what is the difference between the Cost (current US$) in Minerals and Cost (current US$) in Forest?
Keep it short and to the point. -6.74e+07. In the year 2000, what is the difference between the Cost (current US$) in Energy and Cost (current US$) in Forest?
Keep it short and to the point. 6.75e+09. In the year 2003, what is the difference between the Cost (current US$) in CO2 damage and Cost (current US$) in Minerals?
Provide a succinct answer. 1.18e+09. In the year 2003, what is the difference between the Cost (current US$) in CO2 damage and Cost (current US$) in Energy?
Offer a very short reply. -7.27e+09. In the year 2003, what is the difference between the Cost (current US$) of CO2 damage and Cost (current US$) of Forest?
Keep it short and to the point. 1.10e+09. In the year 2003, what is the difference between the Cost (current US$) in Minerals and Cost (current US$) in Energy?
Provide a succinct answer. -8.45e+09. In the year 2003, what is the difference between the Cost (current US$) in Minerals and Cost (current US$) in Forest?
Ensure brevity in your answer.  -8.21e+07. In the year 2003, what is the difference between the Cost (current US$) in Energy and Cost (current US$) in Forest?
Provide a short and direct response. 8.37e+09. In the year 2004, what is the difference between the Cost (current US$) of CO2 damage and Cost (current US$) of Minerals?
Offer a terse response. 1.28e+09. In the year 2004, what is the difference between the Cost (current US$) of CO2 damage and Cost (current US$) of Energy?
Give a very brief answer. -1.01e+1. In the year 2004, what is the difference between the Cost (current US$) in CO2 damage and Cost (current US$) in Forest?
Offer a terse response. 1.15e+09. In the year 2004, what is the difference between the Cost (current US$) in Minerals and Cost (current US$) in Energy?
Provide a succinct answer. -1.14e+1. In the year 2004, what is the difference between the Cost (current US$) in Minerals and Cost (current US$) in Forest?
Ensure brevity in your answer.  -1.32e+08. In the year 2004, what is the difference between the Cost (current US$) of Energy and Cost (current US$) of Forest?
Keep it short and to the point. 1.13e+1. In the year 2005, what is the difference between the Cost (current US$) in CO2 damage and Cost (current US$) in Minerals?
Ensure brevity in your answer.  1.41e+09. In the year 2005, what is the difference between the Cost (current US$) in CO2 damage and Cost (current US$) in Energy?
Your response must be concise. -1.61e+1. In the year 2005, what is the difference between the Cost (current US$) of CO2 damage and Cost (current US$) of Forest?
Your answer should be compact. 1.22e+09. In the year 2005, what is the difference between the Cost (current US$) in Minerals and Cost (current US$) in Energy?
Offer a very short reply. -1.76e+1. In the year 2005, what is the difference between the Cost (current US$) in Minerals and Cost (current US$) in Forest?
Give a very brief answer. -1.93e+08. In the year 2005, what is the difference between the Cost (current US$) in Energy and Cost (current US$) in Forest?
Make the answer very short. 1.74e+1. What is the ratio of the Cost (current US$) in CO2 damage in 1995 to that in 1996?
Your response must be concise. 0.94. What is the ratio of the Cost (current US$) of Minerals in 1995 to that in 1996?
Your answer should be very brief. 1.28. What is the ratio of the Cost (current US$) in Energy in 1995 to that in 1996?
Offer a very short reply. 0.72. What is the ratio of the Cost (current US$) of Forest in 1995 to that in 1996?
Offer a terse response. 1.53. What is the ratio of the Cost (current US$) of CO2 damage in 1995 to that in 1997?
Provide a short and direct response. 0.92. What is the ratio of the Cost (current US$) of Minerals in 1995 to that in 1997?
Give a very brief answer. 1.33. What is the ratio of the Cost (current US$) in Energy in 1995 to that in 1997?
Make the answer very short. 0.76. What is the ratio of the Cost (current US$) in Forest in 1995 to that in 1997?
Your response must be concise. 1.67. What is the ratio of the Cost (current US$) in CO2 damage in 1995 to that in 1998?
Make the answer very short. 0.98. What is the ratio of the Cost (current US$) of Minerals in 1995 to that in 1998?
Give a very brief answer. 2.32. What is the ratio of the Cost (current US$) of Energy in 1995 to that in 1998?
Offer a terse response. 1.12. What is the ratio of the Cost (current US$) in Forest in 1995 to that in 1998?
Your answer should be compact. 91.12. What is the ratio of the Cost (current US$) of CO2 damage in 1995 to that in 1999?
Ensure brevity in your answer.  1.01. What is the ratio of the Cost (current US$) in Minerals in 1995 to that in 1999?
Offer a terse response. 4.56. What is the ratio of the Cost (current US$) in Energy in 1995 to that in 1999?
Your response must be concise. 0.99. What is the ratio of the Cost (current US$) in Forest in 1995 to that in 1999?
Your answer should be very brief. 59.99. What is the ratio of the Cost (current US$) of CO2 damage in 1995 to that in 2000?
Your answer should be very brief. 0.83. What is the ratio of the Cost (current US$) of Minerals in 1995 to that in 2000?
Offer a very short reply. 6. What is the ratio of the Cost (current US$) in Energy in 1995 to that in 2000?
Give a very brief answer. 0.49. What is the ratio of the Cost (current US$) of Forest in 1995 to that in 2000?
Give a very brief answer. 11.66. What is the ratio of the Cost (current US$) in CO2 damage in 1995 to that in 2003?
Offer a very short reply. 0.6. What is the ratio of the Cost (current US$) of Minerals in 1995 to that in 2003?
Ensure brevity in your answer.  2.58. What is the ratio of the Cost (current US$) in Energy in 1995 to that in 2003?
Offer a terse response. 0.39. What is the ratio of the Cost (current US$) of Forest in 1995 to that in 2003?
Give a very brief answer. 8.76. What is the ratio of the Cost (current US$) in CO2 damage in 1995 to that in 2004?
Give a very brief answer. 0.55. What is the ratio of the Cost (current US$) in Minerals in 1995 to that in 2004?
Your response must be concise. 2.3. What is the ratio of the Cost (current US$) of Energy in 1995 to that in 2004?
Your answer should be compact. 0.29. What is the ratio of the Cost (current US$) in Forest in 1995 to that in 2004?
Give a very brief answer. 5.75. What is the ratio of the Cost (current US$) of CO2 damage in 1995 to that in 2005?
Provide a short and direct response. 0.5. What is the ratio of the Cost (current US$) in Minerals in 1995 to that in 2005?
Keep it short and to the point. 1.66. What is the ratio of the Cost (current US$) of Energy in 1995 to that in 2005?
Keep it short and to the point. 0.19. What is the ratio of the Cost (current US$) of Forest in 1995 to that in 2005?
Give a very brief answer. 3.97. What is the ratio of the Cost (current US$) in CO2 damage in 1996 to that in 1997?
Give a very brief answer. 0.98. What is the ratio of the Cost (current US$) in Minerals in 1996 to that in 1997?
Offer a terse response. 1.04. What is the ratio of the Cost (current US$) of Energy in 1996 to that in 1997?
Offer a very short reply. 1.05. What is the ratio of the Cost (current US$) in Forest in 1996 to that in 1997?
Ensure brevity in your answer.  1.09. What is the ratio of the Cost (current US$) in CO2 damage in 1996 to that in 1998?
Offer a very short reply. 1.04. What is the ratio of the Cost (current US$) of Minerals in 1996 to that in 1998?
Your answer should be very brief. 1.81. What is the ratio of the Cost (current US$) of Energy in 1996 to that in 1998?
Your answer should be very brief. 1.55. What is the ratio of the Cost (current US$) of Forest in 1996 to that in 1998?
Provide a succinct answer. 59.57. What is the ratio of the Cost (current US$) of CO2 damage in 1996 to that in 1999?
Provide a short and direct response. 1.07. What is the ratio of the Cost (current US$) of Minerals in 1996 to that in 1999?
Provide a short and direct response. 3.56. What is the ratio of the Cost (current US$) of Energy in 1996 to that in 1999?
Your answer should be very brief. 1.36. What is the ratio of the Cost (current US$) of Forest in 1996 to that in 1999?
Your answer should be very brief. 39.22. What is the ratio of the Cost (current US$) in CO2 damage in 1996 to that in 2000?
Keep it short and to the point. 0.89. What is the ratio of the Cost (current US$) of Minerals in 1996 to that in 2000?
Offer a very short reply. 4.68. What is the ratio of the Cost (current US$) of Energy in 1996 to that in 2000?
Ensure brevity in your answer.  0.67. What is the ratio of the Cost (current US$) in Forest in 1996 to that in 2000?
Your answer should be very brief. 7.63. What is the ratio of the Cost (current US$) of CO2 damage in 1996 to that in 2003?
Keep it short and to the point. 0.64. What is the ratio of the Cost (current US$) in Minerals in 1996 to that in 2003?
Provide a succinct answer. 2.02. What is the ratio of the Cost (current US$) of Energy in 1996 to that in 2003?
Provide a succinct answer. 0.54. What is the ratio of the Cost (current US$) in Forest in 1996 to that in 2003?
Give a very brief answer. 5.73. What is the ratio of the Cost (current US$) of CO2 damage in 1996 to that in 2004?
Your answer should be compact. 0.59. What is the ratio of the Cost (current US$) in Minerals in 1996 to that in 2004?
Offer a terse response. 1.8. What is the ratio of the Cost (current US$) of Energy in 1996 to that in 2004?
Make the answer very short. 0.4. What is the ratio of the Cost (current US$) in Forest in 1996 to that in 2004?
Offer a very short reply. 3.76. What is the ratio of the Cost (current US$) in CO2 damage in 1996 to that in 2005?
Offer a very short reply. 0.53. What is the ratio of the Cost (current US$) in Minerals in 1996 to that in 2005?
Your answer should be compact. 1.29. What is the ratio of the Cost (current US$) in Energy in 1996 to that in 2005?
Your answer should be very brief. 0.26. What is the ratio of the Cost (current US$) of Forest in 1996 to that in 2005?
Provide a short and direct response. 2.59. What is the ratio of the Cost (current US$) of CO2 damage in 1997 to that in 1998?
Give a very brief answer. 1.07. What is the ratio of the Cost (current US$) in Minerals in 1997 to that in 1998?
Your response must be concise. 1.75. What is the ratio of the Cost (current US$) in Energy in 1997 to that in 1998?
Your answer should be very brief. 1.47. What is the ratio of the Cost (current US$) in Forest in 1997 to that in 1998?
Make the answer very short. 54.57. What is the ratio of the Cost (current US$) of CO2 damage in 1997 to that in 1999?
Provide a short and direct response. 1.1. What is the ratio of the Cost (current US$) in Minerals in 1997 to that in 1999?
Your answer should be compact. 3.44. What is the ratio of the Cost (current US$) in Energy in 1997 to that in 1999?
Keep it short and to the point. 1.3. What is the ratio of the Cost (current US$) in Forest in 1997 to that in 1999?
Make the answer very short. 35.92. What is the ratio of the Cost (current US$) in CO2 damage in 1997 to that in 2000?
Give a very brief answer. 0.91. What is the ratio of the Cost (current US$) of Minerals in 1997 to that in 2000?
Give a very brief answer. 4.52. What is the ratio of the Cost (current US$) in Energy in 1997 to that in 2000?
Offer a terse response. 0.64. What is the ratio of the Cost (current US$) of Forest in 1997 to that in 2000?
Your answer should be very brief. 6.98. What is the ratio of the Cost (current US$) in CO2 damage in 1997 to that in 2003?
Give a very brief answer. 0.65. What is the ratio of the Cost (current US$) of Minerals in 1997 to that in 2003?
Offer a terse response. 1.95. What is the ratio of the Cost (current US$) in Energy in 1997 to that in 2003?
Offer a terse response. 0.51. What is the ratio of the Cost (current US$) of Forest in 1997 to that in 2003?
Provide a succinct answer. 5.25. What is the ratio of the Cost (current US$) of CO2 damage in 1997 to that in 2004?
Give a very brief answer. 0.6. What is the ratio of the Cost (current US$) of Minerals in 1997 to that in 2004?
Your answer should be compact. 1.74. What is the ratio of the Cost (current US$) in Energy in 1997 to that in 2004?
Give a very brief answer. 0.38. What is the ratio of the Cost (current US$) of Forest in 1997 to that in 2004?
Your response must be concise. 3.44. What is the ratio of the Cost (current US$) in CO2 damage in 1997 to that in 2005?
Make the answer very short. 0.54. What is the ratio of the Cost (current US$) of Minerals in 1997 to that in 2005?
Provide a short and direct response. 1.25. What is the ratio of the Cost (current US$) of Energy in 1997 to that in 2005?
Offer a terse response. 0.25. What is the ratio of the Cost (current US$) of Forest in 1997 to that in 2005?
Your response must be concise. 2.38. What is the ratio of the Cost (current US$) of CO2 damage in 1998 to that in 1999?
Give a very brief answer. 1.03. What is the ratio of the Cost (current US$) in Minerals in 1998 to that in 1999?
Keep it short and to the point. 1.97. What is the ratio of the Cost (current US$) of Energy in 1998 to that in 1999?
Your response must be concise. 0.88. What is the ratio of the Cost (current US$) of Forest in 1998 to that in 1999?
Offer a very short reply. 0.66. What is the ratio of the Cost (current US$) in CO2 damage in 1998 to that in 2000?
Make the answer very short. 0.85. What is the ratio of the Cost (current US$) in Minerals in 1998 to that in 2000?
Give a very brief answer. 2.59. What is the ratio of the Cost (current US$) in Energy in 1998 to that in 2000?
Make the answer very short. 0.43. What is the ratio of the Cost (current US$) in Forest in 1998 to that in 2000?
Provide a short and direct response. 0.13. What is the ratio of the Cost (current US$) in CO2 damage in 1998 to that in 2003?
Your answer should be very brief. 0.61. What is the ratio of the Cost (current US$) of Minerals in 1998 to that in 2003?
Give a very brief answer. 1.12. What is the ratio of the Cost (current US$) in Energy in 1998 to that in 2003?
Offer a terse response. 0.35. What is the ratio of the Cost (current US$) of Forest in 1998 to that in 2003?
Provide a short and direct response. 0.1. What is the ratio of the Cost (current US$) in CO2 damage in 1998 to that in 2004?
Your answer should be compact. 0.56. What is the ratio of the Cost (current US$) of Minerals in 1998 to that in 2004?
Keep it short and to the point. 0.99. What is the ratio of the Cost (current US$) of Energy in 1998 to that in 2004?
Your response must be concise. 0.26. What is the ratio of the Cost (current US$) in Forest in 1998 to that in 2004?
Ensure brevity in your answer.  0.06. What is the ratio of the Cost (current US$) of CO2 damage in 1998 to that in 2005?
Your response must be concise. 0.51. What is the ratio of the Cost (current US$) of Minerals in 1998 to that in 2005?
Your answer should be very brief. 0.71. What is the ratio of the Cost (current US$) in Energy in 1998 to that in 2005?
Give a very brief answer. 0.17. What is the ratio of the Cost (current US$) in Forest in 1998 to that in 2005?
Give a very brief answer. 0.04. What is the ratio of the Cost (current US$) in CO2 damage in 1999 to that in 2000?
Your answer should be compact. 0.82. What is the ratio of the Cost (current US$) in Minerals in 1999 to that in 2000?
Your answer should be very brief. 1.32. What is the ratio of the Cost (current US$) of Energy in 1999 to that in 2000?
Your answer should be compact. 0.49. What is the ratio of the Cost (current US$) in Forest in 1999 to that in 2000?
Ensure brevity in your answer.  0.19. What is the ratio of the Cost (current US$) in CO2 damage in 1999 to that in 2003?
Provide a short and direct response. 0.59. What is the ratio of the Cost (current US$) in Minerals in 1999 to that in 2003?
Provide a succinct answer. 0.57. What is the ratio of the Cost (current US$) of Energy in 1999 to that in 2003?
Provide a succinct answer. 0.4. What is the ratio of the Cost (current US$) of Forest in 1999 to that in 2003?
Your answer should be compact. 0.15. What is the ratio of the Cost (current US$) of CO2 damage in 1999 to that in 2004?
Keep it short and to the point. 0.55. What is the ratio of the Cost (current US$) of Minerals in 1999 to that in 2004?
Offer a terse response. 0.51. What is the ratio of the Cost (current US$) of Energy in 1999 to that in 2004?
Provide a short and direct response. 0.29. What is the ratio of the Cost (current US$) in Forest in 1999 to that in 2004?
Your answer should be very brief. 0.1. What is the ratio of the Cost (current US$) in CO2 damage in 1999 to that in 2005?
Your response must be concise. 0.49. What is the ratio of the Cost (current US$) in Minerals in 1999 to that in 2005?
Give a very brief answer. 0.36. What is the ratio of the Cost (current US$) of Energy in 1999 to that in 2005?
Give a very brief answer. 0.19. What is the ratio of the Cost (current US$) in Forest in 1999 to that in 2005?
Provide a succinct answer. 0.07. What is the ratio of the Cost (current US$) of CO2 damage in 2000 to that in 2003?
Offer a very short reply. 0.72. What is the ratio of the Cost (current US$) of Minerals in 2000 to that in 2003?
Provide a short and direct response. 0.43. What is the ratio of the Cost (current US$) of Energy in 2000 to that in 2003?
Provide a succinct answer. 0.81. What is the ratio of the Cost (current US$) of Forest in 2000 to that in 2003?
Keep it short and to the point. 0.75. What is the ratio of the Cost (current US$) in CO2 damage in 2000 to that in 2004?
Make the answer very short. 0.66. What is the ratio of the Cost (current US$) of Minerals in 2000 to that in 2004?
Your response must be concise. 0.38. What is the ratio of the Cost (current US$) in Energy in 2000 to that in 2004?
Ensure brevity in your answer.  0.6. What is the ratio of the Cost (current US$) of Forest in 2000 to that in 2004?
Provide a short and direct response. 0.49. What is the ratio of the Cost (current US$) in CO2 damage in 2000 to that in 2005?
Offer a terse response. 0.6. What is the ratio of the Cost (current US$) of Minerals in 2000 to that in 2005?
Provide a succinct answer. 0.28. What is the ratio of the Cost (current US$) of Energy in 2000 to that in 2005?
Provide a short and direct response. 0.39. What is the ratio of the Cost (current US$) of Forest in 2000 to that in 2005?
Your response must be concise. 0.34. What is the ratio of the Cost (current US$) of CO2 damage in 2003 to that in 2004?
Provide a succinct answer. 0.92. What is the ratio of the Cost (current US$) of Minerals in 2003 to that in 2004?
Offer a terse response. 0.89. What is the ratio of the Cost (current US$) in Energy in 2003 to that in 2004?
Keep it short and to the point. 0.74. What is the ratio of the Cost (current US$) in Forest in 2003 to that in 2004?
Your answer should be compact. 0.66. What is the ratio of the Cost (current US$) of CO2 damage in 2003 to that in 2005?
Offer a very short reply. 0.83. What is the ratio of the Cost (current US$) in Minerals in 2003 to that in 2005?
Provide a succinct answer. 0.64. What is the ratio of the Cost (current US$) in Energy in 2003 to that in 2005?
Your answer should be compact. 0.48. What is the ratio of the Cost (current US$) in Forest in 2003 to that in 2005?
Give a very brief answer. 0.45. What is the ratio of the Cost (current US$) of CO2 damage in 2004 to that in 2005?
Provide a succinct answer. 0.9. What is the ratio of the Cost (current US$) in Minerals in 2004 to that in 2005?
Your answer should be very brief. 0.72. What is the ratio of the Cost (current US$) of Energy in 2004 to that in 2005?
Your response must be concise. 0.65. What is the ratio of the Cost (current US$) in Forest in 2004 to that in 2005?
Ensure brevity in your answer.  0.69. What is the difference between the highest and the second highest Cost (current US$) in CO2 damage?
Your response must be concise. 1.38e+08. What is the difference between the highest and the second highest Cost (current US$) in Minerals?
Your response must be concise. 1.02e+07. What is the difference between the highest and the second highest Cost (current US$) in Energy?
Ensure brevity in your answer.  6.14e+09. What is the difference between the highest and the second highest Cost (current US$) of Forest?
Your response must be concise. 3.04e+08. What is the difference between the highest and the lowest Cost (current US$) of CO2 damage?
Give a very brief answer. 7.27e+08. What is the difference between the highest and the lowest Cost (current US$) of Minerals?
Your response must be concise. 3.89e+07. What is the difference between the highest and the lowest Cost (current US$) in Energy?
Make the answer very short. 1.46e+1. What is the difference between the highest and the lowest Cost (current US$) in Forest?
Provide a short and direct response. 8.68e+08. 